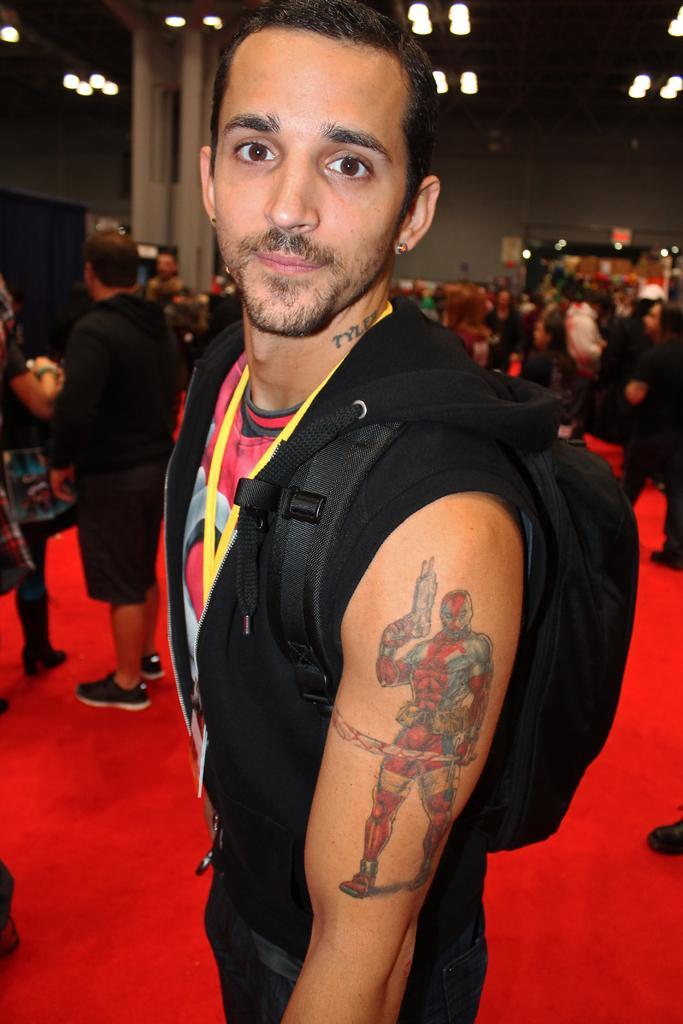Describe this image in one or two sentences. In this picture I can see in the middle a man is standing, he is wearing black color sweater and a bag, in the background a group of people are there. At the top there are ceiling lights. 